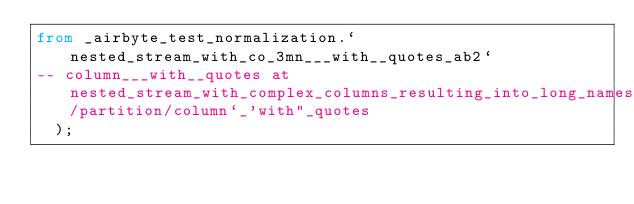<code> <loc_0><loc_0><loc_500><loc_500><_SQL_>from _airbyte_test_normalization.`nested_stream_with_co_3mn___with__quotes_ab2`
-- column___with__quotes at nested_stream_with_complex_columns_resulting_into_long_names/partition/column`_'with"_quotes
  );
</code> 